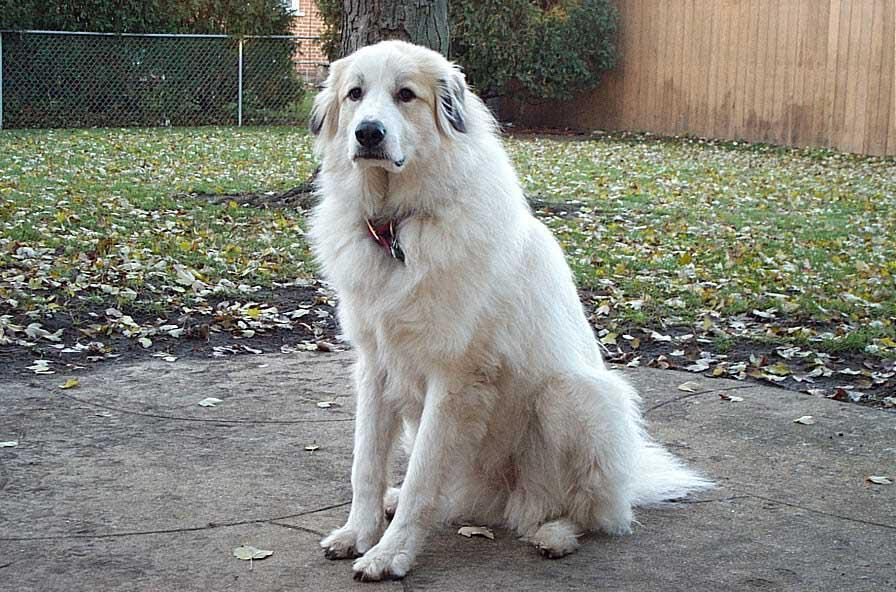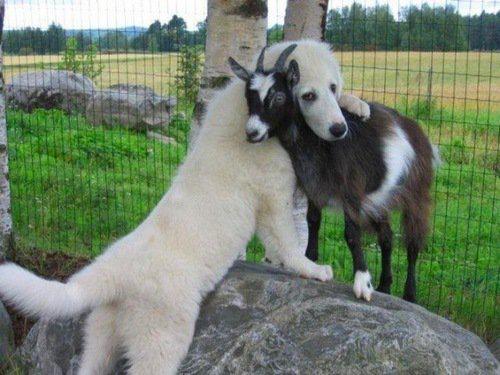The first image is the image on the left, the second image is the image on the right. Given the left and right images, does the statement "Each image contains no more than one white dog, the dog in the right image is outdoors, and at least one dog wears a collar." hold true? Answer yes or no. Yes. The first image is the image on the left, the second image is the image on the right. Analyze the images presented: Is the assertion "One dog has its mouth open." valid? Answer yes or no. No. 